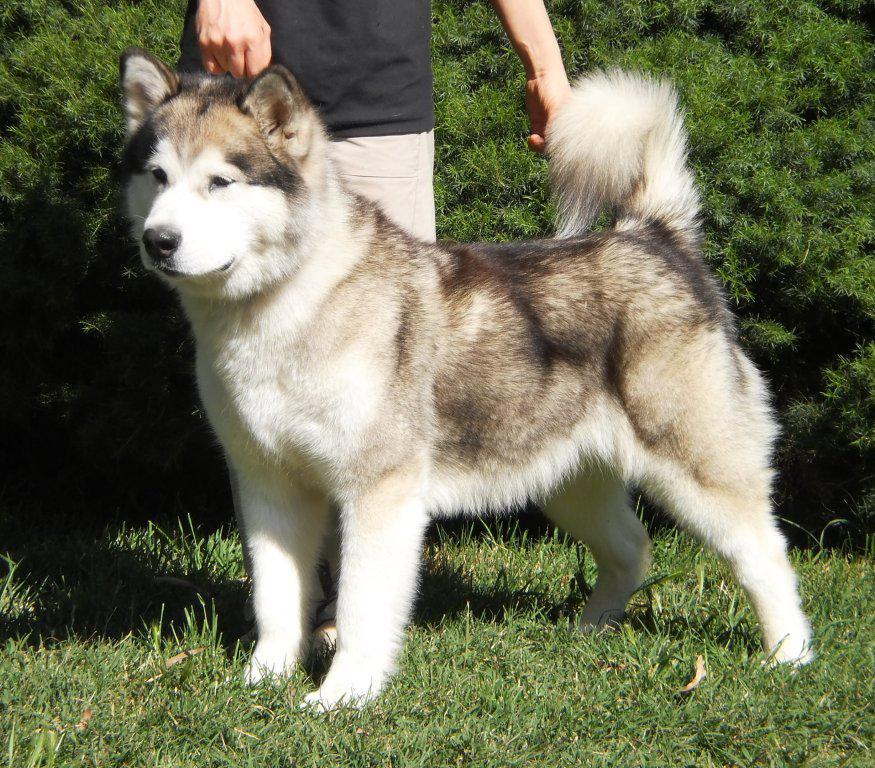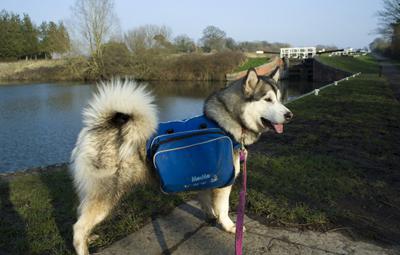The first image is the image on the left, the second image is the image on the right. Examine the images to the left and right. Is the description "At least one of the dogs does not have a backpack on its back." accurate? Answer yes or no. Yes. The first image is the image on the left, the second image is the image on the right. Considering the images on both sides, is "In the left image, two furry dogs are seen wearing packs on their backs." valid? Answer yes or no. No. 